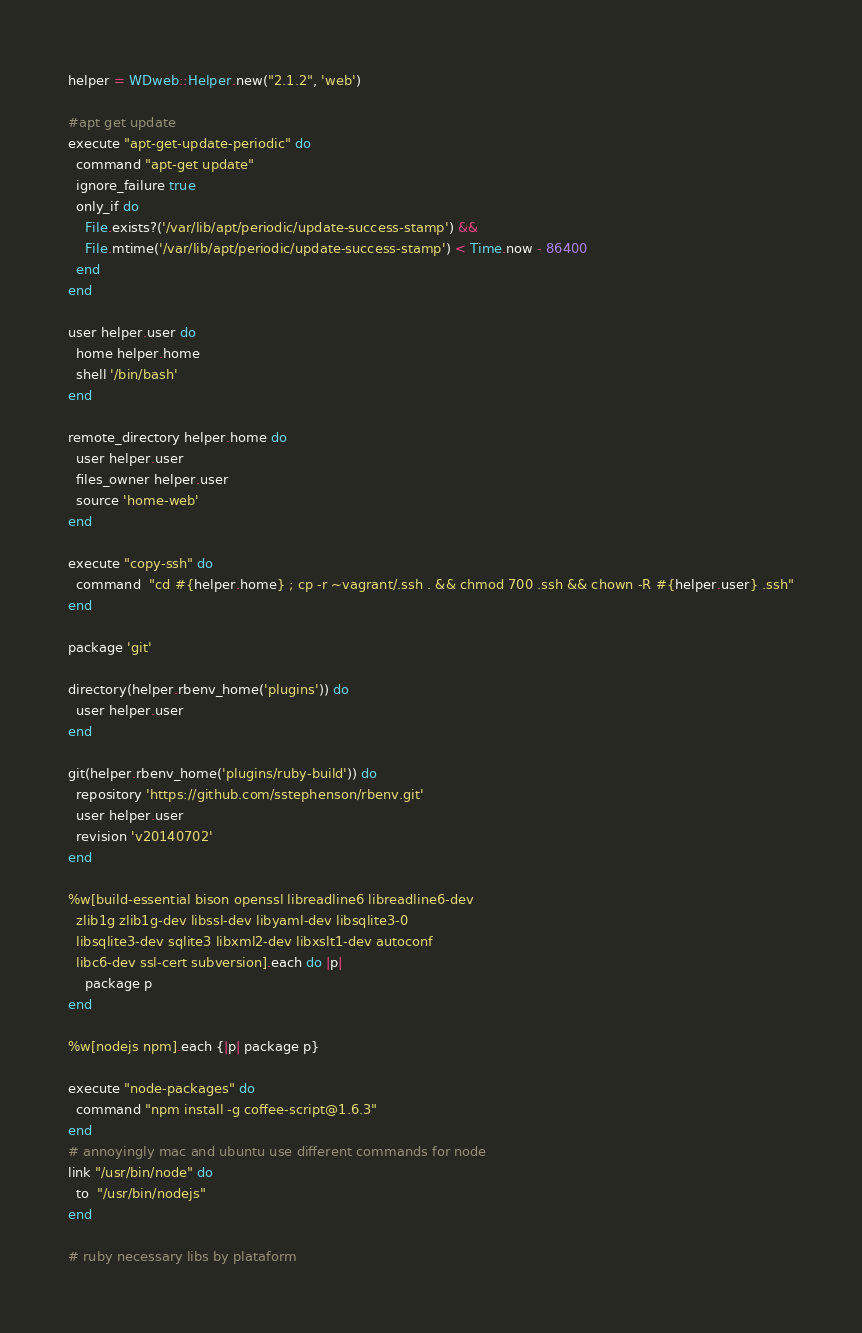<code> <loc_0><loc_0><loc_500><loc_500><_Ruby_>helper = WDweb::Helper.new("2.1.2", 'web')

#apt get update
execute "apt-get-update-periodic" do
  command "apt-get update"
  ignore_failure true
  only_if do
    File.exists?('/var/lib/apt/periodic/update-success-stamp') &&
    File.mtime('/var/lib/apt/periodic/update-success-stamp') < Time.now - 86400
  end
end

user helper.user do
  home helper.home
  shell '/bin/bash'
end

remote_directory helper.home do
  user helper.user
  files_owner helper.user
  source 'home-web'
end

execute "copy-ssh" do
  command  "cd #{helper.home} ; cp -r ~vagrant/.ssh . && chmod 700 .ssh && chown -R #{helper.user} .ssh"
end

package 'git'

directory(helper.rbenv_home('plugins')) do
  user helper.user
end

git(helper.rbenv_home('plugins/ruby-build')) do
  repository 'https://github.com/sstephenson/rbenv.git'
  user helper.user
  revision 'v20140702'
end

%w[build-essential bison openssl libreadline6 libreadline6-dev
  zlib1g zlib1g-dev libssl-dev libyaml-dev libsqlite3-0
  libsqlite3-dev sqlite3 libxml2-dev libxslt1-dev autoconf
  libc6-dev ssl-cert subversion].each do |p|
    package p
end

%w[nodejs npm].each {|p| package p}

execute "node-packages" do
  command "npm install -g coffee-script@1.6.3"
end
# annoyingly mac and ubuntu use different commands for node
link "/usr/bin/node" do
  to  "/usr/bin/nodejs"
end

# ruby necessary libs by plataform</code> 